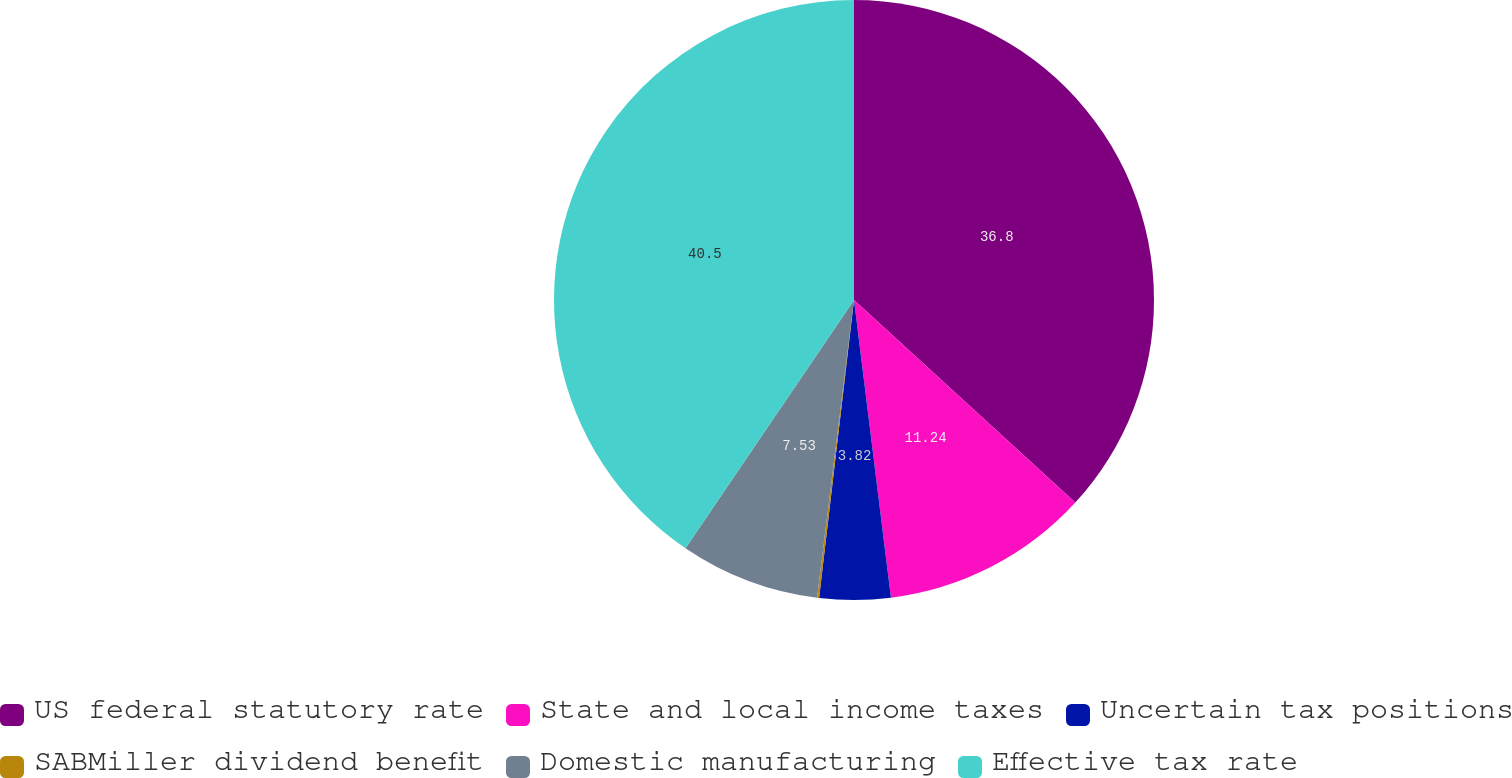Convert chart. <chart><loc_0><loc_0><loc_500><loc_500><pie_chart><fcel>US federal statutory rate<fcel>State and local income taxes<fcel>Uncertain tax positions<fcel>SABMiller dividend benefit<fcel>Domestic manufacturing<fcel>Effective tax rate<nl><fcel>36.8%<fcel>11.24%<fcel>3.82%<fcel>0.11%<fcel>7.53%<fcel>40.51%<nl></chart> 